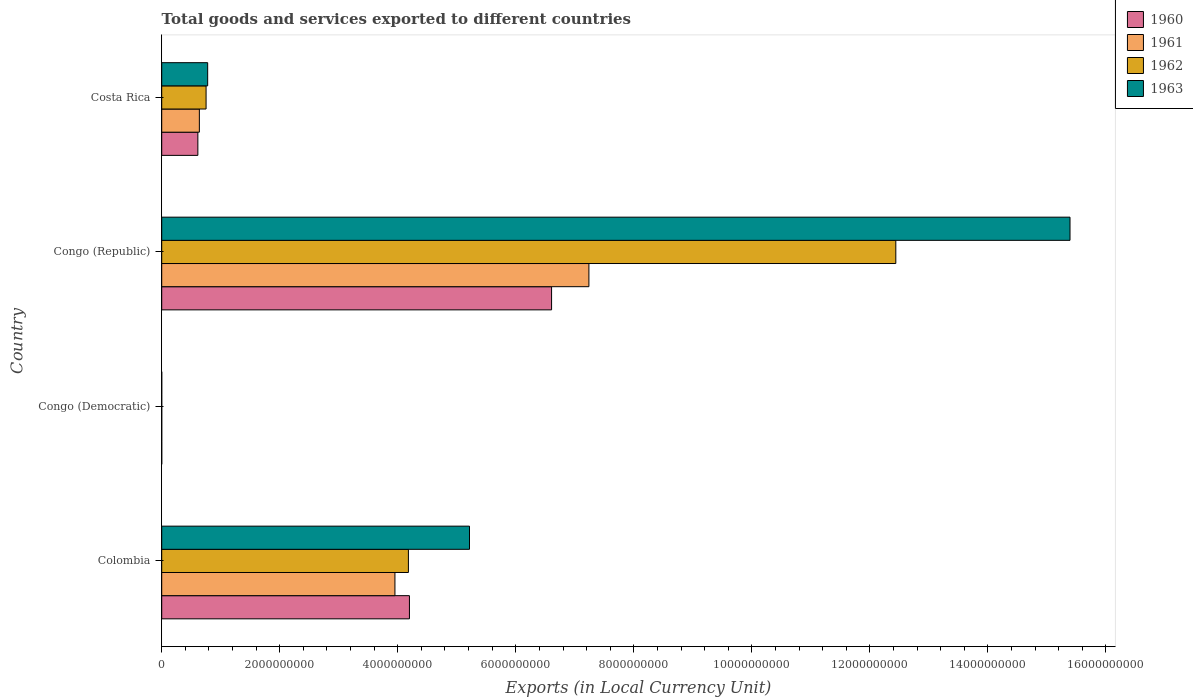How many groups of bars are there?
Keep it short and to the point. 4. Are the number of bars per tick equal to the number of legend labels?
Your answer should be very brief. Yes. How many bars are there on the 2nd tick from the top?
Keep it short and to the point. 4. How many bars are there on the 2nd tick from the bottom?
Offer a very short reply. 4. What is the label of the 4th group of bars from the top?
Your answer should be compact. Colombia. In how many cases, is the number of bars for a given country not equal to the number of legend labels?
Offer a very short reply. 0. What is the Amount of goods and services exports in 1961 in Congo (Democratic)?
Provide a short and direct response. 5.32500016561244e-5. Across all countries, what is the maximum Amount of goods and services exports in 1963?
Your answer should be very brief. 1.54e+1. Across all countries, what is the minimum Amount of goods and services exports in 1963?
Your answer should be very brief. 0. In which country was the Amount of goods and services exports in 1962 maximum?
Give a very brief answer. Congo (Republic). In which country was the Amount of goods and services exports in 1963 minimum?
Ensure brevity in your answer.  Congo (Democratic). What is the total Amount of goods and services exports in 1960 in the graph?
Your answer should be very brief. 1.14e+1. What is the difference between the Amount of goods and services exports in 1961 in Congo (Republic) and that in Costa Rica?
Your response must be concise. 6.60e+09. What is the difference between the Amount of goods and services exports in 1962 in Congo (Democratic) and the Amount of goods and services exports in 1961 in Colombia?
Provide a succinct answer. -3.95e+09. What is the average Amount of goods and services exports in 1961 per country?
Your answer should be very brief. 2.96e+09. What is the difference between the Amount of goods and services exports in 1960 and Amount of goods and services exports in 1963 in Congo (Republic)?
Your answer should be very brief. -8.79e+09. What is the ratio of the Amount of goods and services exports in 1960 in Colombia to that in Congo (Democratic)?
Your answer should be compact. 3.89e+13. Is the Amount of goods and services exports in 1962 in Colombia less than that in Congo (Democratic)?
Keep it short and to the point. No. What is the difference between the highest and the second highest Amount of goods and services exports in 1960?
Give a very brief answer. 2.41e+09. What is the difference between the highest and the lowest Amount of goods and services exports in 1962?
Provide a short and direct response. 1.24e+1. Is the sum of the Amount of goods and services exports in 1963 in Congo (Republic) and Costa Rica greater than the maximum Amount of goods and services exports in 1960 across all countries?
Your answer should be very brief. Yes. Is it the case that in every country, the sum of the Amount of goods and services exports in 1963 and Amount of goods and services exports in 1961 is greater than the sum of Amount of goods and services exports in 1962 and Amount of goods and services exports in 1960?
Keep it short and to the point. No. What does the 1st bar from the bottom in Congo (Republic) represents?
Offer a very short reply. 1960. How many bars are there?
Offer a very short reply. 16. Are all the bars in the graph horizontal?
Offer a terse response. Yes. Are the values on the major ticks of X-axis written in scientific E-notation?
Make the answer very short. No. Does the graph contain any zero values?
Provide a short and direct response. No. Does the graph contain grids?
Your answer should be very brief. No. How many legend labels are there?
Offer a very short reply. 4. How are the legend labels stacked?
Provide a succinct answer. Vertical. What is the title of the graph?
Offer a very short reply. Total goods and services exported to different countries. Does "2010" appear as one of the legend labels in the graph?
Offer a very short reply. No. What is the label or title of the X-axis?
Give a very brief answer. Exports (in Local Currency Unit). What is the Exports (in Local Currency Unit) of 1960 in Colombia?
Ensure brevity in your answer.  4.20e+09. What is the Exports (in Local Currency Unit) in 1961 in Colombia?
Your response must be concise. 3.95e+09. What is the Exports (in Local Currency Unit) in 1962 in Colombia?
Offer a terse response. 4.18e+09. What is the Exports (in Local Currency Unit) in 1963 in Colombia?
Give a very brief answer. 5.22e+09. What is the Exports (in Local Currency Unit) of 1960 in Congo (Democratic)?
Keep it short and to the point. 0. What is the Exports (in Local Currency Unit) in 1961 in Congo (Democratic)?
Make the answer very short. 5.32500016561244e-5. What is the Exports (in Local Currency Unit) of 1962 in Congo (Democratic)?
Give a very brief answer. 6.15126409684308e-5. What is the Exports (in Local Currency Unit) in 1963 in Congo (Democratic)?
Offer a terse response. 0. What is the Exports (in Local Currency Unit) of 1960 in Congo (Republic)?
Provide a succinct answer. 6.61e+09. What is the Exports (in Local Currency Unit) of 1961 in Congo (Republic)?
Ensure brevity in your answer.  7.24e+09. What is the Exports (in Local Currency Unit) of 1962 in Congo (Republic)?
Make the answer very short. 1.24e+1. What is the Exports (in Local Currency Unit) of 1963 in Congo (Republic)?
Keep it short and to the point. 1.54e+1. What is the Exports (in Local Currency Unit) in 1960 in Costa Rica?
Offer a very short reply. 6.13e+08. What is the Exports (in Local Currency Unit) of 1961 in Costa Rica?
Offer a very short reply. 6.38e+08. What is the Exports (in Local Currency Unit) in 1962 in Costa Rica?
Make the answer very short. 7.52e+08. What is the Exports (in Local Currency Unit) of 1963 in Costa Rica?
Ensure brevity in your answer.  7.79e+08. Across all countries, what is the maximum Exports (in Local Currency Unit) in 1960?
Make the answer very short. 6.61e+09. Across all countries, what is the maximum Exports (in Local Currency Unit) in 1961?
Give a very brief answer. 7.24e+09. Across all countries, what is the maximum Exports (in Local Currency Unit) in 1962?
Provide a succinct answer. 1.24e+1. Across all countries, what is the maximum Exports (in Local Currency Unit) of 1963?
Your response must be concise. 1.54e+1. Across all countries, what is the minimum Exports (in Local Currency Unit) of 1960?
Make the answer very short. 0. Across all countries, what is the minimum Exports (in Local Currency Unit) in 1961?
Your response must be concise. 5.32500016561244e-5. Across all countries, what is the minimum Exports (in Local Currency Unit) in 1962?
Ensure brevity in your answer.  6.15126409684308e-5. Across all countries, what is the minimum Exports (in Local Currency Unit) in 1963?
Ensure brevity in your answer.  0. What is the total Exports (in Local Currency Unit) of 1960 in the graph?
Ensure brevity in your answer.  1.14e+1. What is the total Exports (in Local Currency Unit) of 1961 in the graph?
Provide a short and direct response. 1.18e+1. What is the total Exports (in Local Currency Unit) of 1962 in the graph?
Offer a very short reply. 1.74e+1. What is the total Exports (in Local Currency Unit) of 1963 in the graph?
Your answer should be compact. 2.14e+1. What is the difference between the Exports (in Local Currency Unit) in 1960 in Colombia and that in Congo (Democratic)?
Make the answer very short. 4.20e+09. What is the difference between the Exports (in Local Currency Unit) in 1961 in Colombia and that in Congo (Democratic)?
Provide a short and direct response. 3.95e+09. What is the difference between the Exports (in Local Currency Unit) in 1962 in Colombia and that in Congo (Democratic)?
Keep it short and to the point. 4.18e+09. What is the difference between the Exports (in Local Currency Unit) in 1963 in Colombia and that in Congo (Democratic)?
Provide a short and direct response. 5.22e+09. What is the difference between the Exports (in Local Currency Unit) of 1960 in Colombia and that in Congo (Republic)?
Provide a succinct answer. -2.41e+09. What is the difference between the Exports (in Local Currency Unit) in 1961 in Colombia and that in Congo (Republic)?
Provide a short and direct response. -3.29e+09. What is the difference between the Exports (in Local Currency Unit) of 1962 in Colombia and that in Congo (Republic)?
Provide a succinct answer. -8.26e+09. What is the difference between the Exports (in Local Currency Unit) of 1963 in Colombia and that in Congo (Republic)?
Provide a succinct answer. -1.02e+1. What is the difference between the Exports (in Local Currency Unit) in 1960 in Colombia and that in Costa Rica?
Provide a succinct answer. 3.59e+09. What is the difference between the Exports (in Local Currency Unit) of 1961 in Colombia and that in Costa Rica?
Provide a succinct answer. 3.31e+09. What is the difference between the Exports (in Local Currency Unit) of 1962 in Colombia and that in Costa Rica?
Keep it short and to the point. 3.43e+09. What is the difference between the Exports (in Local Currency Unit) of 1963 in Colombia and that in Costa Rica?
Provide a short and direct response. 4.44e+09. What is the difference between the Exports (in Local Currency Unit) in 1960 in Congo (Democratic) and that in Congo (Republic)?
Keep it short and to the point. -6.61e+09. What is the difference between the Exports (in Local Currency Unit) in 1961 in Congo (Democratic) and that in Congo (Republic)?
Provide a short and direct response. -7.24e+09. What is the difference between the Exports (in Local Currency Unit) of 1962 in Congo (Democratic) and that in Congo (Republic)?
Your answer should be compact. -1.24e+1. What is the difference between the Exports (in Local Currency Unit) in 1963 in Congo (Democratic) and that in Congo (Republic)?
Provide a short and direct response. -1.54e+1. What is the difference between the Exports (in Local Currency Unit) of 1960 in Congo (Democratic) and that in Costa Rica?
Provide a short and direct response. -6.13e+08. What is the difference between the Exports (in Local Currency Unit) in 1961 in Congo (Democratic) and that in Costa Rica?
Make the answer very short. -6.38e+08. What is the difference between the Exports (in Local Currency Unit) of 1962 in Congo (Democratic) and that in Costa Rica?
Offer a terse response. -7.52e+08. What is the difference between the Exports (in Local Currency Unit) of 1963 in Congo (Democratic) and that in Costa Rica?
Give a very brief answer. -7.79e+08. What is the difference between the Exports (in Local Currency Unit) in 1960 in Congo (Republic) and that in Costa Rica?
Ensure brevity in your answer.  5.99e+09. What is the difference between the Exports (in Local Currency Unit) in 1961 in Congo (Republic) and that in Costa Rica?
Provide a succinct answer. 6.60e+09. What is the difference between the Exports (in Local Currency Unit) of 1962 in Congo (Republic) and that in Costa Rica?
Ensure brevity in your answer.  1.17e+1. What is the difference between the Exports (in Local Currency Unit) of 1963 in Congo (Republic) and that in Costa Rica?
Keep it short and to the point. 1.46e+1. What is the difference between the Exports (in Local Currency Unit) of 1960 in Colombia and the Exports (in Local Currency Unit) of 1961 in Congo (Democratic)?
Your answer should be compact. 4.20e+09. What is the difference between the Exports (in Local Currency Unit) of 1960 in Colombia and the Exports (in Local Currency Unit) of 1962 in Congo (Democratic)?
Provide a short and direct response. 4.20e+09. What is the difference between the Exports (in Local Currency Unit) of 1960 in Colombia and the Exports (in Local Currency Unit) of 1963 in Congo (Democratic)?
Give a very brief answer. 4.20e+09. What is the difference between the Exports (in Local Currency Unit) in 1961 in Colombia and the Exports (in Local Currency Unit) in 1962 in Congo (Democratic)?
Your answer should be compact. 3.95e+09. What is the difference between the Exports (in Local Currency Unit) in 1961 in Colombia and the Exports (in Local Currency Unit) in 1963 in Congo (Democratic)?
Give a very brief answer. 3.95e+09. What is the difference between the Exports (in Local Currency Unit) in 1962 in Colombia and the Exports (in Local Currency Unit) in 1963 in Congo (Democratic)?
Your answer should be very brief. 4.18e+09. What is the difference between the Exports (in Local Currency Unit) in 1960 in Colombia and the Exports (in Local Currency Unit) in 1961 in Congo (Republic)?
Offer a terse response. -3.04e+09. What is the difference between the Exports (in Local Currency Unit) of 1960 in Colombia and the Exports (in Local Currency Unit) of 1962 in Congo (Republic)?
Your answer should be very brief. -8.24e+09. What is the difference between the Exports (in Local Currency Unit) in 1960 in Colombia and the Exports (in Local Currency Unit) in 1963 in Congo (Republic)?
Provide a succinct answer. -1.12e+1. What is the difference between the Exports (in Local Currency Unit) of 1961 in Colombia and the Exports (in Local Currency Unit) of 1962 in Congo (Republic)?
Provide a short and direct response. -8.49e+09. What is the difference between the Exports (in Local Currency Unit) of 1961 in Colombia and the Exports (in Local Currency Unit) of 1963 in Congo (Republic)?
Ensure brevity in your answer.  -1.14e+1. What is the difference between the Exports (in Local Currency Unit) of 1962 in Colombia and the Exports (in Local Currency Unit) of 1963 in Congo (Republic)?
Offer a very short reply. -1.12e+1. What is the difference between the Exports (in Local Currency Unit) in 1960 in Colombia and the Exports (in Local Currency Unit) in 1961 in Costa Rica?
Make the answer very short. 3.56e+09. What is the difference between the Exports (in Local Currency Unit) of 1960 in Colombia and the Exports (in Local Currency Unit) of 1962 in Costa Rica?
Provide a short and direct response. 3.45e+09. What is the difference between the Exports (in Local Currency Unit) in 1960 in Colombia and the Exports (in Local Currency Unit) in 1963 in Costa Rica?
Your answer should be very brief. 3.42e+09. What is the difference between the Exports (in Local Currency Unit) of 1961 in Colombia and the Exports (in Local Currency Unit) of 1962 in Costa Rica?
Your response must be concise. 3.20e+09. What is the difference between the Exports (in Local Currency Unit) in 1961 in Colombia and the Exports (in Local Currency Unit) in 1963 in Costa Rica?
Your answer should be compact. 3.17e+09. What is the difference between the Exports (in Local Currency Unit) in 1962 in Colombia and the Exports (in Local Currency Unit) in 1963 in Costa Rica?
Make the answer very short. 3.40e+09. What is the difference between the Exports (in Local Currency Unit) in 1960 in Congo (Democratic) and the Exports (in Local Currency Unit) in 1961 in Congo (Republic)?
Ensure brevity in your answer.  -7.24e+09. What is the difference between the Exports (in Local Currency Unit) of 1960 in Congo (Democratic) and the Exports (in Local Currency Unit) of 1962 in Congo (Republic)?
Keep it short and to the point. -1.24e+1. What is the difference between the Exports (in Local Currency Unit) of 1960 in Congo (Democratic) and the Exports (in Local Currency Unit) of 1963 in Congo (Republic)?
Provide a short and direct response. -1.54e+1. What is the difference between the Exports (in Local Currency Unit) in 1961 in Congo (Democratic) and the Exports (in Local Currency Unit) in 1962 in Congo (Republic)?
Your answer should be compact. -1.24e+1. What is the difference between the Exports (in Local Currency Unit) of 1961 in Congo (Democratic) and the Exports (in Local Currency Unit) of 1963 in Congo (Republic)?
Provide a succinct answer. -1.54e+1. What is the difference between the Exports (in Local Currency Unit) of 1962 in Congo (Democratic) and the Exports (in Local Currency Unit) of 1963 in Congo (Republic)?
Give a very brief answer. -1.54e+1. What is the difference between the Exports (in Local Currency Unit) of 1960 in Congo (Democratic) and the Exports (in Local Currency Unit) of 1961 in Costa Rica?
Provide a succinct answer. -6.38e+08. What is the difference between the Exports (in Local Currency Unit) of 1960 in Congo (Democratic) and the Exports (in Local Currency Unit) of 1962 in Costa Rica?
Provide a short and direct response. -7.52e+08. What is the difference between the Exports (in Local Currency Unit) in 1960 in Congo (Democratic) and the Exports (in Local Currency Unit) in 1963 in Costa Rica?
Ensure brevity in your answer.  -7.79e+08. What is the difference between the Exports (in Local Currency Unit) of 1961 in Congo (Democratic) and the Exports (in Local Currency Unit) of 1962 in Costa Rica?
Provide a short and direct response. -7.52e+08. What is the difference between the Exports (in Local Currency Unit) of 1961 in Congo (Democratic) and the Exports (in Local Currency Unit) of 1963 in Costa Rica?
Keep it short and to the point. -7.79e+08. What is the difference between the Exports (in Local Currency Unit) of 1962 in Congo (Democratic) and the Exports (in Local Currency Unit) of 1963 in Costa Rica?
Make the answer very short. -7.79e+08. What is the difference between the Exports (in Local Currency Unit) in 1960 in Congo (Republic) and the Exports (in Local Currency Unit) in 1961 in Costa Rica?
Make the answer very short. 5.97e+09. What is the difference between the Exports (in Local Currency Unit) in 1960 in Congo (Republic) and the Exports (in Local Currency Unit) in 1962 in Costa Rica?
Your answer should be very brief. 5.85e+09. What is the difference between the Exports (in Local Currency Unit) of 1960 in Congo (Republic) and the Exports (in Local Currency Unit) of 1963 in Costa Rica?
Your response must be concise. 5.83e+09. What is the difference between the Exports (in Local Currency Unit) of 1961 in Congo (Republic) and the Exports (in Local Currency Unit) of 1962 in Costa Rica?
Your response must be concise. 6.49e+09. What is the difference between the Exports (in Local Currency Unit) in 1961 in Congo (Republic) and the Exports (in Local Currency Unit) in 1963 in Costa Rica?
Ensure brevity in your answer.  6.46e+09. What is the difference between the Exports (in Local Currency Unit) in 1962 in Congo (Republic) and the Exports (in Local Currency Unit) in 1963 in Costa Rica?
Your answer should be compact. 1.17e+1. What is the average Exports (in Local Currency Unit) in 1960 per country?
Your response must be concise. 2.85e+09. What is the average Exports (in Local Currency Unit) of 1961 per country?
Ensure brevity in your answer.  2.96e+09. What is the average Exports (in Local Currency Unit) of 1962 per country?
Keep it short and to the point. 4.34e+09. What is the average Exports (in Local Currency Unit) in 1963 per country?
Offer a very short reply. 5.35e+09. What is the difference between the Exports (in Local Currency Unit) of 1960 and Exports (in Local Currency Unit) of 1961 in Colombia?
Ensure brevity in your answer.  2.46e+08. What is the difference between the Exports (in Local Currency Unit) of 1960 and Exports (in Local Currency Unit) of 1962 in Colombia?
Your answer should be very brief. 1.74e+07. What is the difference between the Exports (in Local Currency Unit) in 1960 and Exports (in Local Currency Unit) in 1963 in Colombia?
Keep it short and to the point. -1.02e+09. What is the difference between the Exports (in Local Currency Unit) in 1961 and Exports (in Local Currency Unit) in 1962 in Colombia?
Keep it short and to the point. -2.28e+08. What is the difference between the Exports (in Local Currency Unit) of 1961 and Exports (in Local Currency Unit) of 1963 in Colombia?
Your answer should be very brief. -1.26e+09. What is the difference between the Exports (in Local Currency Unit) in 1962 and Exports (in Local Currency Unit) in 1963 in Colombia?
Your response must be concise. -1.04e+09. What is the difference between the Exports (in Local Currency Unit) of 1960 and Exports (in Local Currency Unit) of 1963 in Congo (Democratic)?
Make the answer very short. -0. What is the difference between the Exports (in Local Currency Unit) in 1961 and Exports (in Local Currency Unit) in 1963 in Congo (Democratic)?
Your answer should be very brief. -0. What is the difference between the Exports (in Local Currency Unit) in 1962 and Exports (in Local Currency Unit) in 1963 in Congo (Democratic)?
Keep it short and to the point. -0. What is the difference between the Exports (in Local Currency Unit) in 1960 and Exports (in Local Currency Unit) in 1961 in Congo (Republic)?
Offer a very short reply. -6.33e+08. What is the difference between the Exports (in Local Currency Unit) in 1960 and Exports (in Local Currency Unit) in 1962 in Congo (Republic)?
Provide a short and direct response. -5.83e+09. What is the difference between the Exports (in Local Currency Unit) of 1960 and Exports (in Local Currency Unit) of 1963 in Congo (Republic)?
Provide a succinct answer. -8.79e+09. What is the difference between the Exports (in Local Currency Unit) in 1961 and Exports (in Local Currency Unit) in 1962 in Congo (Republic)?
Ensure brevity in your answer.  -5.20e+09. What is the difference between the Exports (in Local Currency Unit) in 1961 and Exports (in Local Currency Unit) in 1963 in Congo (Republic)?
Your answer should be compact. -8.15e+09. What is the difference between the Exports (in Local Currency Unit) in 1962 and Exports (in Local Currency Unit) in 1963 in Congo (Republic)?
Ensure brevity in your answer.  -2.95e+09. What is the difference between the Exports (in Local Currency Unit) of 1960 and Exports (in Local Currency Unit) of 1961 in Costa Rica?
Your answer should be compact. -2.54e+07. What is the difference between the Exports (in Local Currency Unit) of 1960 and Exports (in Local Currency Unit) of 1962 in Costa Rica?
Provide a short and direct response. -1.39e+08. What is the difference between the Exports (in Local Currency Unit) in 1960 and Exports (in Local Currency Unit) in 1963 in Costa Rica?
Provide a succinct answer. -1.66e+08. What is the difference between the Exports (in Local Currency Unit) in 1961 and Exports (in Local Currency Unit) in 1962 in Costa Rica?
Your answer should be very brief. -1.14e+08. What is the difference between the Exports (in Local Currency Unit) in 1961 and Exports (in Local Currency Unit) in 1963 in Costa Rica?
Your answer should be very brief. -1.41e+08. What is the difference between the Exports (in Local Currency Unit) in 1962 and Exports (in Local Currency Unit) in 1963 in Costa Rica?
Offer a terse response. -2.71e+07. What is the ratio of the Exports (in Local Currency Unit) of 1960 in Colombia to that in Congo (Democratic)?
Give a very brief answer. 3.89e+13. What is the ratio of the Exports (in Local Currency Unit) of 1961 in Colombia to that in Congo (Democratic)?
Your response must be concise. 7.42e+13. What is the ratio of the Exports (in Local Currency Unit) of 1962 in Colombia to that in Congo (Democratic)?
Your answer should be very brief. 6.80e+13. What is the ratio of the Exports (in Local Currency Unit) of 1963 in Colombia to that in Congo (Democratic)?
Give a very brief answer. 1.05e+13. What is the ratio of the Exports (in Local Currency Unit) of 1960 in Colombia to that in Congo (Republic)?
Offer a terse response. 0.64. What is the ratio of the Exports (in Local Currency Unit) of 1961 in Colombia to that in Congo (Republic)?
Your answer should be compact. 0.55. What is the ratio of the Exports (in Local Currency Unit) of 1962 in Colombia to that in Congo (Republic)?
Keep it short and to the point. 0.34. What is the ratio of the Exports (in Local Currency Unit) of 1963 in Colombia to that in Congo (Republic)?
Your response must be concise. 0.34. What is the ratio of the Exports (in Local Currency Unit) of 1960 in Colombia to that in Costa Rica?
Give a very brief answer. 6.85. What is the ratio of the Exports (in Local Currency Unit) in 1961 in Colombia to that in Costa Rica?
Your answer should be very brief. 6.19. What is the ratio of the Exports (in Local Currency Unit) in 1962 in Colombia to that in Costa Rica?
Keep it short and to the point. 5.56. What is the ratio of the Exports (in Local Currency Unit) of 1963 in Colombia to that in Costa Rica?
Make the answer very short. 6.7. What is the ratio of the Exports (in Local Currency Unit) of 1960 in Congo (Democratic) to that in Congo (Republic)?
Keep it short and to the point. 0. What is the ratio of the Exports (in Local Currency Unit) in 1961 in Congo (Democratic) to that in Congo (Republic)?
Provide a succinct answer. 0. What is the ratio of the Exports (in Local Currency Unit) in 1962 in Congo (Democratic) to that in Congo (Republic)?
Your answer should be very brief. 0. What is the ratio of the Exports (in Local Currency Unit) in 1963 in Congo (Democratic) to that in Congo (Republic)?
Your answer should be compact. 0. What is the ratio of the Exports (in Local Currency Unit) of 1962 in Congo (Democratic) to that in Costa Rica?
Keep it short and to the point. 0. What is the ratio of the Exports (in Local Currency Unit) in 1960 in Congo (Republic) to that in Costa Rica?
Keep it short and to the point. 10.78. What is the ratio of the Exports (in Local Currency Unit) of 1961 in Congo (Republic) to that in Costa Rica?
Your response must be concise. 11.35. What is the ratio of the Exports (in Local Currency Unit) in 1962 in Congo (Republic) to that in Costa Rica?
Keep it short and to the point. 16.55. What is the ratio of the Exports (in Local Currency Unit) in 1963 in Congo (Republic) to that in Costa Rica?
Your answer should be compact. 19.76. What is the difference between the highest and the second highest Exports (in Local Currency Unit) of 1960?
Make the answer very short. 2.41e+09. What is the difference between the highest and the second highest Exports (in Local Currency Unit) of 1961?
Your answer should be compact. 3.29e+09. What is the difference between the highest and the second highest Exports (in Local Currency Unit) of 1962?
Your answer should be compact. 8.26e+09. What is the difference between the highest and the second highest Exports (in Local Currency Unit) in 1963?
Provide a succinct answer. 1.02e+1. What is the difference between the highest and the lowest Exports (in Local Currency Unit) in 1960?
Make the answer very short. 6.61e+09. What is the difference between the highest and the lowest Exports (in Local Currency Unit) in 1961?
Provide a succinct answer. 7.24e+09. What is the difference between the highest and the lowest Exports (in Local Currency Unit) of 1962?
Keep it short and to the point. 1.24e+1. What is the difference between the highest and the lowest Exports (in Local Currency Unit) in 1963?
Your response must be concise. 1.54e+1. 